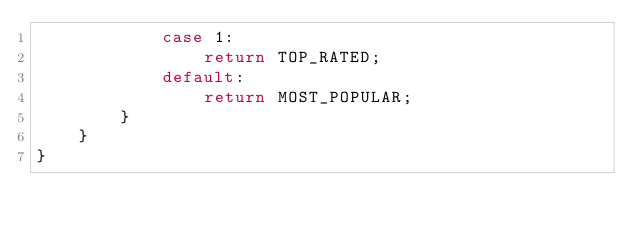<code> <loc_0><loc_0><loc_500><loc_500><_Java_>            case 1:
                return TOP_RATED;
            default:
                return MOST_POPULAR;
        }
    }
}
</code> 